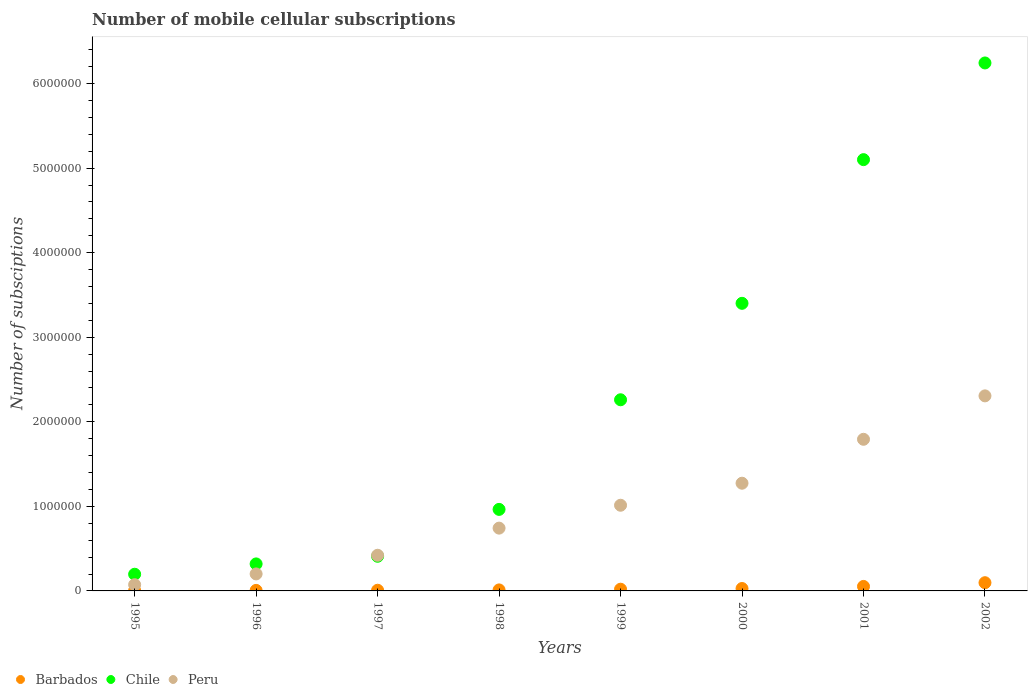Is the number of dotlines equal to the number of legend labels?
Offer a terse response. Yes. What is the number of mobile cellular subscriptions in Chile in 1995?
Make the answer very short. 1.97e+05. Across all years, what is the maximum number of mobile cellular subscriptions in Chile?
Your answer should be compact. 6.24e+06. Across all years, what is the minimum number of mobile cellular subscriptions in Peru?
Your answer should be very brief. 7.35e+04. In which year was the number of mobile cellular subscriptions in Barbados minimum?
Make the answer very short. 1995. What is the total number of mobile cellular subscriptions in Barbados in the graph?
Keep it short and to the point. 2.30e+05. What is the difference between the number of mobile cellular subscriptions in Peru in 1996 and that in 1998?
Make the answer very short. -5.42e+05. What is the difference between the number of mobile cellular subscriptions in Barbados in 1999 and the number of mobile cellular subscriptions in Peru in 1996?
Offer a terse response. -1.81e+05. What is the average number of mobile cellular subscriptions in Barbados per year?
Keep it short and to the point. 2.87e+04. In the year 1999, what is the difference between the number of mobile cellular subscriptions in Barbados and number of mobile cellular subscriptions in Peru?
Make the answer very short. -9.93e+05. In how many years, is the number of mobile cellular subscriptions in Peru greater than 3400000?
Make the answer very short. 0. What is the ratio of the number of mobile cellular subscriptions in Barbados in 1999 to that in 2000?
Your answer should be compact. 0.71. Is the number of mobile cellular subscriptions in Chile in 1998 less than that in 1999?
Your answer should be compact. Yes. Is the difference between the number of mobile cellular subscriptions in Barbados in 1999 and 2000 greater than the difference between the number of mobile cellular subscriptions in Peru in 1999 and 2000?
Provide a succinct answer. Yes. What is the difference between the highest and the second highest number of mobile cellular subscriptions in Chile?
Give a very brief answer. 1.14e+06. What is the difference between the highest and the lowest number of mobile cellular subscriptions in Barbados?
Offer a terse response. 9.26e+04. Does the number of mobile cellular subscriptions in Chile monotonically increase over the years?
Your answer should be very brief. Yes. Is the number of mobile cellular subscriptions in Chile strictly less than the number of mobile cellular subscriptions in Barbados over the years?
Provide a succinct answer. No. How many dotlines are there?
Provide a succinct answer. 3. What is the difference between two consecutive major ticks on the Y-axis?
Provide a short and direct response. 1.00e+06. Does the graph contain grids?
Your answer should be compact. No. How many legend labels are there?
Keep it short and to the point. 3. How are the legend labels stacked?
Offer a terse response. Horizontal. What is the title of the graph?
Give a very brief answer. Number of mobile cellular subscriptions. What is the label or title of the Y-axis?
Your response must be concise. Number of subsciptions. What is the Number of subsciptions in Barbados in 1995?
Offer a terse response. 4614. What is the Number of subsciptions of Chile in 1995?
Your answer should be very brief. 1.97e+05. What is the Number of subsciptions in Peru in 1995?
Provide a short and direct response. 7.35e+04. What is the Number of subsciptions in Barbados in 1996?
Your answer should be compact. 6283. What is the Number of subsciptions of Chile in 1996?
Your answer should be compact. 3.19e+05. What is the Number of subsciptions of Peru in 1996?
Offer a very short reply. 2.01e+05. What is the Number of subsciptions of Barbados in 1997?
Your answer should be compact. 8013. What is the Number of subsciptions in Chile in 1997?
Keep it short and to the point. 4.10e+05. What is the Number of subsciptions in Peru in 1997?
Offer a terse response. 4.22e+05. What is the Number of subsciptions of Barbados in 1998?
Make the answer very short. 1.20e+04. What is the Number of subsciptions in Chile in 1998?
Your answer should be very brief. 9.64e+05. What is the Number of subsciptions of Peru in 1998?
Your response must be concise. 7.43e+05. What is the Number of subsciptions of Barbados in 1999?
Your response must be concise. 2.03e+04. What is the Number of subsciptions in Chile in 1999?
Your response must be concise. 2.26e+06. What is the Number of subsciptions in Peru in 1999?
Keep it short and to the point. 1.01e+06. What is the Number of subsciptions in Barbados in 2000?
Provide a short and direct response. 2.85e+04. What is the Number of subsciptions in Chile in 2000?
Ensure brevity in your answer.  3.40e+06. What is the Number of subsciptions of Peru in 2000?
Make the answer very short. 1.27e+06. What is the Number of subsciptions of Barbados in 2001?
Offer a very short reply. 5.31e+04. What is the Number of subsciptions of Chile in 2001?
Make the answer very short. 5.10e+06. What is the Number of subsciptions of Peru in 2001?
Offer a terse response. 1.79e+06. What is the Number of subsciptions of Barbados in 2002?
Offer a very short reply. 9.72e+04. What is the Number of subsciptions of Chile in 2002?
Make the answer very short. 6.24e+06. What is the Number of subsciptions of Peru in 2002?
Keep it short and to the point. 2.31e+06. Across all years, what is the maximum Number of subsciptions in Barbados?
Your answer should be compact. 9.72e+04. Across all years, what is the maximum Number of subsciptions in Chile?
Your response must be concise. 6.24e+06. Across all years, what is the maximum Number of subsciptions in Peru?
Your answer should be compact. 2.31e+06. Across all years, what is the minimum Number of subsciptions in Barbados?
Offer a terse response. 4614. Across all years, what is the minimum Number of subsciptions in Chile?
Offer a terse response. 1.97e+05. Across all years, what is the minimum Number of subsciptions of Peru?
Keep it short and to the point. 7.35e+04. What is the total Number of subsciptions in Barbados in the graph?
Make the answer very short. 2.30e+05. What is the total Number of subsciptions in Chile in the graph?
Offer a terse response. 1.89e+07. What is the total Number of subsciptions in Peru in the graph?
Keep it short and to the point. 7.83e+06. What is the difference between the Number of subsciptions of Barbados in 1995 and that in 1996?
Your answer should be very brief. -1669. What is the difference between the Number of subsciptions of Chile in 1995 and that in 1996?
Give a very brief answer. -1.22e+05. What is the difference between the Number of subsciptions of Peru in 1995 and that in 1996?
Provide a succinct answer. -1.27e+05. What is the difference between the Number of subsciptions in Barbados in 1995 and that in 1997?
Give a very brief answer. -3399. What is the difference between the Number of subsciptions of Chile in 1995 and that in 1997?
Offer a very short reply. -2.12e+05. What is the difference between the Number of subsciptions of Peru in 1995 and that in 1997?
Provide a succinct answer. -3.48e+05. What is the difference between the Number of subsciptions in Barbados in 1995 and that in 1998?
Your answer should be compact. -7386. What is the difference between the Number of subsciptions of Chile in 1995 and that in 1998?
Provide a short and direct response. -7.67e+05. What is the difference between the Number of subsciptions in Peru in 1995 and that in 1998?
Offer a very short reply. -6.69e+05. What is the difference between the Number of subsciptions in Barbados in 1995 and that in 1999?
Your answer should be very brief. -1.57e+04. What is the difference between the Number of subsciptions of Chile in 1995 and that in 1999?
Make the answer very short. -2.06e+06. What is the difference between the Number of subsciptions in Peru in 1995 and that in 1999?
Provide a succinct answer. -9.40e+05. What is the difference between the Number of subsciptions in Barbados in 1995 and that in 2000?
Offer a terse response. -2.39e+04. What is the difference between the Number of subsciptions of Chile in 1995 and that in 2000?
Provide a succinct answer. -3.20e+06. What is the difference between the Number of subsciptions in Peru in 1995 and that in 2000?
Your answer should be compact. -1.20e+06. What is the difference between the Number of subsciptions of Barbados in 1995 and that in 2001?
Offer a terse response. -4.85e+04. What is the difference between the Number of subsciptions of Chile in 1995 and that in 2001?
Your answer should be very brief. -4.90e+06. What is the difference between the Number of subsciptions of Peru in 1995 and that in 2001?
Offer a very short reply. -1.72e+06. What is the difference between the Number of subsciptions in Barbados in 1995 and that in 2002?
Your answer should be compact. -9.26e+04. What is the difference between the Number of subsciptions of Chile in 1995 and that in 2002?
Offer a terse response. -6.05e+06. What is the difference between the Number of subsciptions of Peru in 1995 and that in 2002?
Your response must be concise. -2.23e+06. What is the difference between the Number of subsciptions in Barbados in 1996 and that in 1997?
Ensure brevity in your answer.  -1730. What is the difference between the Number of subsciptions in Chile in 1996 and that in 1997?
Your response must be concise. -9.03e+04. What is the difference between the Number of subsciptions of Peru in 1996 and that in 1997?
Your answer should be very brief. -2.21e+05. What is the difference between the Number of subsciptions in Barbados in 1996 and that in 1998?
Your answer should be very brief. -5717. What is the difference between the Number of subsciptions in Chile in 1996 and that in 1998?
Offer a very short reply. -6.45e+05. What is the difference between the Number of subsciptions of Peru in 1996 and that in 1998?
Provide a succinct answer. -5.42e+05. What is the difference between the Number of subsciptions in Barbados in 1996 and that in 1999?
Give a very brief answer. -1.40e+04. What is the difference between the Number of subsciptions in Chile in 1996 and that in 1999?
Provide a short and direct response. -1.94e+06. What is the difference between the Number of subsciptions of Peru in 1996 and that in 1999?
Offer a terse response. -8.12e+05. What is the difference between the Number of subsciptions of Barbados in 1996 and that in 2000?
Give a very brief answer. -2.22e+04. What is the difference between the Number of subsciptions of Chile in 1996 and that in 2000?
Offer a very short reply. -3.08e+06. What is the difference between the Number of subsciptions in Peru in 1996 and that in 2000?
Make the answer very short. -1.07e+06. What is the difference between the Number of subsciptions in Barbados in 1996 and that in 2001?
Offer a very short reply. -4.68e+04. What is the difference between the Number of subsciptions of Chile in 1996 and that in 2001?
Offer a terse response. -4.78e+06. What is the difference between the Number of subsciptions in Peru in 1996 and that in 2001?
Your answer should be compact. -1.59e+06. What is the difference between the Number of subsciptions of Barbados in 1996 and that in 2002?
Your answer should be very brief. -9.09e+04. What is the difference between the Number of subsciptions of Chile in 1996 and that in 2002?
Give a very brief answer. -5.92e+06. What is the difference between the Number of subsciptions in Peru in 1996 and that in 2002?
Offer a terse response. -2.11e+06. What is the difference between the Number of subsciptions in Barbados in 1997 and that in 1998?
Provide a short and direct response. -3987. What is the difference between the Number of subsciptions in Chile in 1997 and that in 1998?
Provide a succinct answer. -5.55e+05. What is the difference between the Number of subsciptions of Peru in 1997 and that in 1998?
Offer a terse response. -3.21e+05. What is the difference between the Number of subsciptions of Barbados in 1997 and that in 1999?
Your answer should be compact. -1.23e+04. What is the difference between the Number of subsciptions in Chile in 1997 and that in 1999?
Offer a very short reply. -1.85e+06. What is the difference between the Number of subsciptions in Peru in 1997 and that in 1999?
Keep it short and to the point. -5.92e+05. What is the difference between the Number of subsciptions in Barbados in 1997 and that in 2000?
Make the answer very short. -2.05e+04. What is the difference between the Number of subsciptions in Chile in 1997 and that in 2000?
Offer a very short reply. -2.99e+06. What is the difference between the Number of subsciptions in Peru in 1997 and that in 2000?
Offer a very short reply. -8.52e+05. What is the difference between the Number of subsciptions of Barbados in 1997 and that in 2001?
Keep it short and to the point. -4.51e+04. What is the difference between the Number of subsciptions in Chile in 1997 and that in 2001?
Provide a succinct answer. -4.69e+06. What is the difference between the Number of subsciptions in Peru in 1997 and that in 2001?
Your response must be concise. -1.37e+06. What is the difference between the Number of subsciptions in Barbados in 1997 and that in 2002?
Your answer should be compact. -8.92e+04. What is the difference between the Number of subsciptions in Chile in 1997 and that in 2002?
Keep it short and to the point. -5.83e+06. What is the difference between the Number of subsciptions of Peru in 1997 and that in 2002?
Your answer should be compact. -1.89e+06. What is the difference between the Number of subsciptions of Barbados in 1998 and that in 1999?
Keep it short and to the point. -8309. What is the difference between the Number of subsciptions of Chile in 1998 and that in 1999?
Offer a very short reply. -1.30e+06. What is the difference between the Number of subsciptions of Peru in 1998 and that in 1999?
Offer a very short reply. -2.71e+05. What is the difference between the Number of subsciptions in Barbados in 1998 and that in 2000?
Provide a succinct answer. -1.65e+04. What is the difference between the Number of subsciptions in Chile in 1998 and that in 2000?
Keep it short and to the point. -2.44e+06. What is the difference between the Number of subsciptions of Peru in 1998 and that in 2000?
Your response must be concise. -5.31e+05. What is the difference between the Number of subsciptions in Barbados in 1998 and that in 2001?
Provide a succinct answer. -4.11e+04. What is the difference between the Number of subsciptions of Chile in 1998 and that in 2001?
Keep it short and to the point. -4.14e+06. What is the difference between the Number of subsciptions of Peru in 1998 and that in 2001?
Offer a very short reply. -1.05e+06. What is the difference between the Number of subsciptions of Barbados in 1998 and that in 2002?
Offer a very short reply. -8.52e+04. What is the difference between the Number of subsciptions of Chile in 1998 and that in 2002?
Provide a short and direct response. -5.28e+06. What is the difference between the Number of subsciptions in Peru in 1998 and that in 2002?
Provide a short and direct response. -1.56e+06. What is the difference between the Number of subsciptions of Barbados in 1999 and that in 2000?
Your response must be concise. -8158. What is the difference between the Number of subsciptions of Chile in 1999 and that in 2000?
Offer a terse response. -1.14e+06. What is the difference between the Number of subsciptions of Peru in 1999 and that in 2000?
Ensure brevity in your answer.  -2.61e+05. What is the difference between the Number of subsciptions of Barbados in 1999 and that in 2001?
Ensure brevity in your answer.  -3.28e+04. What is the difference between the Number of subsciptions in Chile in 1999 and that in 2001?
Your answer should be very brief. -2.84e+06. What is the difference between the Number of subsciptions of Peru in 1999 and that in 2001?
Your answer should be compact. -7.80e+05. What is the difference between the Number of subsciptions in Barbados in 1999 and that in 2002?
Offer a very short reply. -7.69e+04. What is the difference between the Number of subsciptions in Chile in 1999 and that in 2002?
Ensure brevity in your answer.  -3.98e+06. What is the difference between the Number of subsciptions of Peru in 1999 and that in 2002?
Offer a very short reply. -1.29e+06. What is the difference between the Number of subsciptions of Barbados in 2000 and that in 2001?
Your answer should be very brief. -2.46e+04. What is the difference between the Number of subsciptions in Chile in 2000 and that in 2001?
Provide a succinct answer. -1.70e+06. What is the difference between the Number of subsciptions of Peru in 2000 and that in 2001?
Offer a terse response. -5.19e+05. What is the difference between the Number of subsciptions in Barbados in 2000 and that in 2002?
Your response must be concise. -6.87e+04. What is the difference between the Number of subsciptions in Chile in 2000 and that in 2002?
Offer a terse response. -2.84e+06. What is the difference between the Number of subsciptions of Peru in 2000 and that in 2002?
Make the answer very short. -1.03e+06. What is the difference between the Number of subsciptions in Barbados in 2001 and that in 2002?
Your answer should be very brief. -4.41e+04. What is the difference between the Number of subsciptions of Chile in 2001 and that in 2002?
Make the answer very short. -1.14e+06. What is the difference between the Number of subsciptions of Peru in 2001 and that in 2002?
Your response must be concise. -5.14e+05. What is the difference between the Number of subsciptions in Barbados in 1995 and the Number of subsciptions in Chile in 1996?
Make the answer very short. -3.15e+05. What is the difference between the Number of subsciptions in Barbados in 1995 and the Number of subsciptions in Peru in 1996?
Provide a short and direct response. -1.96e+05. What is the difference between the Number of subsciptions of Chile in 1995 and the Number of subsciptions of Peru in 1996?
Your answer should be compact. -3658. What is the difference between the Number of subsciptions in Barbados in 1995 and the Number of subsciptions in Chile in 1997?
Give a very brief answer. -4.05e+05. What is the difference between the Number of subsciptions in Barbados in 1995 and the Number of subsciptions in Peru in 1997?
Keep it short and to the point. -4.17e+05. What is the difference between the Number of subsciptions of Chile in 1995 and the Number of subsciptions of Peru in 1997?
Make the answer very short. -2.24e+05. What is the difference between the Number of subsciptions of Barbados in 1995 and the Number of subsciptions of Chile in 1998?
Offer a very short reply. -9.60e+05. What is the difference between the Number of subsciptions of Barbados in 1995 and the Number of subsciptions of Peru in 1998?
Provide a succinct answer. -7.38e+05. What is the difference between the Number of subsciptions in Chile in 1995 and the Number of subsciptions in Peru in 1998?
Offer a very short reply. -5.45e+05. What is the difference between the Number of subsciptions of Barbados in 1995 and the Number of subsciptions of Chile in 1999?
Your answer should be very brief. -2.26e+06. What is the difference between the Number of subsciptions of Barbados in 1995 and the Number of subsciptions of Peru in 1999?
Keep it short and to the point. -1.01e+06. What is the difference between the Number of subsciptions of Chile in 1995 and the Number of subsciptions of Peru in 1999?
Your response must be concise. -8.16e+05. What is the difference between the Number of subsciptions of Barbados in 1995 and the Number of subsciptions of Chile in 2000?
Offer a very short reply. -3.40e+06. What is the difference between the Number of subsciptions in Barbados in 1995 and the Number of subsciptions in Peru in 2000?
Ensure brevity in your answer.  -1.27e+06. What is the difference between the Number of subsciptions in Chile in 1995 and the Number of subsciptions in Peru in 2000?
Ensure brevity in your answer.  -1.08e+06. What is the difference between the Number of subsciptions in Barbados in 1995 and the Number of subsciptions in Chile in 2001?
Your response must be concise. -5.10e+06. What is the difference between the Number of subsciptions in Barbados in 1995 and the Number of subsciptions in Peru in 2001?
Keep it short and to the point. -1.79e+06. What is the difference between the Number of subsciptions of Chile in 1995 and the Number of subsciptions of Peru in 2001?
Your response must be concise. -1.60e+06. What is the difference between the Number of subsciptions in Barbados in 1995 and the Number of subsciptions in Chile in 2002?
Ensure brevity in your answer.  -6.24e+06. What is the difference between the Number of subsciptions of Barbados in 1995 and the Number of subsciptions of Peru in 2002?
Your answer should be compact. -2.30e+06. What is the difference between the Number of subsciptions in Chile in 1995 and the Number of subsciptions in Peru in 2002?
Your answer should be very brief. -2.11e+06. What is the difference between the Number of subsciptions in Barbados in 1996 and the Number of subsciptions in Chile in 1997?
Keep it short and to the point. -4.03e+05. What is the difference between the Number of subsciptions of Barbados in 1996 and the Number of subsciptions of Peru in 1997?
Keep it short and to the point. -4.16e+05. What is the difference between the Number of subsciptions in Chile in 1996 and the Number of subsciptions in Peru in 1997?
Provide a succinct answer. -1.02e+05. What is the difference between the Number of subsciptions in Barbados in 1996 and the Number of subsciptions in Chile in 1998?
Offer a very short reply. -9.58e+05. What is the difference between the Number of subsciptions in Barbados in 1996 and the Number of subsciptions in Peru in 1998?
Ensure brevity in your answer.  -7.36e+05. What is the difference between the Number of subsciptions of Chile in 1996 and the Number of subsciptions of Peru in 1998?
Your answer should be compact. -4.23e+05. What is the difference between the Number of subsciptions of Barbados in 1996 and the Number of subsciptions of Chile in 1999?
Your answer should be very brief. -2.25e+06. What is the difference between the Number of subsciptions in Barbados in 1996 and the Number of subsciptions in Peru in 1999?
Offer a very short reply. -1.01e+06. What is the difference between the Number of subsciptions of Chile in 1996 and the Number of subsciptions of Peru in 1999?
Provide a short and direct response. -6.94e+05. What is the difference between the Number of subsciptions of Barbados in 1996 and the Number of subsciptions of Chile in 2000?
Provide a short and direct response. -3.40e+06. What is the difference between the Number of subsciptions of Barbados in 1996 and the Number of subsciptions of Peru in 2000?
Your response must be concise. -1.27e+06. What is the difference between the Number of subsciptions in Chile in 1996 and the Number of subsciptions in Peru in 2000?
Make the answer very short. -9.54e+05. What is the difference between the Number of subsciptions of Barbados in 1996 and the Number of subsciptions of Chile in 2001?
Offer a very short reply. -5.09e+06. What is the difference between the Number of subsciptions of Barbados in 1996 and the Number of subsciptions of Peru in 2001?
Offer a very short reply. -1.79e+06. What is the difference between the Number of subsciptions of Chile in 1996 and the Number of subsciptions of Peru in 2001?
Give a very brief answer. -1.47e+06. What is the difference between the Number of subsciptions of Barbados in 1996 and the Number of subsciptions of Chile in 2002?
Offer a very short reply. -6.24e+06. What is the difference between the Number of subsciptions of Barbados in 1996 and the Number of subsciptions of Peru in 2002?
Ensure brevity in your answer.  -2.30e+06. What is the difference between the Number of subsciptions of Chile in 1996 and the Number of subsciptions of Peru in 2002?
Keep it short and to the point. -1.99e+06. What is the difference between the Number of subsciptions of Barbados in 1997 and the Number of subsciptions of Chile in 1998?
Offer a terse response. -9.56e+05. What is the difference between the Number of subsciptions in Barbados in 1997 and the Number of subsciptions in Peru in 1998?
Your answer should be very brief. -7.35e+05. What is the difference between the Number of subsciptions of Chile in 1997 and the Number of subsciptions of Peru in 1998?
Provide a succinct answer. -3.33e+05. What is the difference between the Number of subsciptions of Barbados in 1997 and the Number of subsciptions of Chile in 1999?
Your answer should be compact. -2.25e+06. What is the difference between the Number of subsciptions in Barbados in 1997 and the Number of subsciptions in Peru in 1999?
Your response must be concise. -1.01e+06. What is the difference between the Number of subsciptions in Chile in 1997 and the Number of subsciptions in Peru in 1999?
Offer a very short reply. -6.04e+05. What is the difference between the Number of subsciptions of Barbados in 1997 and the Number of subsciptions of Chile in 2000?
Give a very brief answer. -3.39e+06. What is the difference between the Number of subsciptions in Barbados in 1997 and the Number of subsciptions in Peru in 2000?
Your answer should be very brief. -1.27e+06. What is the difference between the Number of subsciptions in Chile in 1997 and the Number of subsciptions in Peru in 2000?
Your answer should be compact. -8.64e+05. What is the difference between the Number of subsciptions in Barbados in 1997 and the Number of subsciptions in Chile in 2001?
Offer a terse response. -5.09e+06. What is the difference between the Number of subsciptions in Barbados in 1997 and the Number of subsciptions in Peru in 2001?
Ensure brevity in your answer.  -1.79e+06. What is the difference between the Number of subsciptions of Chile in 1997 and the Number of subsciptions of Peru in 2001?
Offer a very short reply. -1.38e+06. What is the difference between the Number of subsciptions of Barbados in 1997 and the Number of subsciptions of Chile in 2002?
Your response must be concise. -6.24e+06. What is the difference between the Number of subsciptions of Barbados in 1997 and the Number of subsciptions of Peru in 2002?
Your response must be concise. -2.30e+06. What is the difference between the Number of subsciptions of Chile in 1997 and the Number of subsciptions of Peru in 2002?
Provide a short and direct response. -1.90e+06. What is the difference between the Number of subsciptions of Barbados in 1998 and the Number of subsciptions of Chile in 1999?
Your answer should be very brief. -2.25e+06. What is the difference between the Number of subsciptions of Barbados in 1998 and the Number of subsciptions of Peru in 1999?
Provide a short and direct response. -1.00e+06. What is the difference between the Number of subsciptions of Chile in 1998 and the Number of subsciptions of Peru in 1999?
Give a very brief answer. -4.91e+04. What is the difference between the Number of subsciptions in Barbados in 1998 and the Number of subsciptions in Chile in 2000?
Your answer should be very brief. -3.39e+06. What is the difference between the Number of subsciptions of Barbados in 1998 and the Number of subsciptions of Peru in 2000?
Your answer should be very brief. -1.26e+06. What is the difference between the Number of subsciptions in Chile in 1998 and the Number of subsciptions in Peru in 2000?
Offer a terse response. -3.10e+05. What is the difference between the Number of subsciptions in Barbados in 1998 and the Number of subsciptions in Chile in 2001?
Ensure brevity in your answer.  -5.09e+06. What is the difference between the Number of subsciptions in Barbados in 1998 and the Number of subsciptions in Peru in 2001?
Ensure brevity in your answer.  -1.78e+06. What is the difference between the Number of subsciptions in Chile in 1998 and the Number of subsciptions in Peru in 2001?
Your answer should be compact. -8.29e+05. What is the difference between the Number of subsciptions of Barbados in 1998 and the Number of subsciptions of Chile in 2002?
Your response must be concise. -6.23e+06. What is the difference between the Number of subsciptions in Barbados in 1998 and the Number of subsciptions in Peru in 2002?
Make the answer very short. -2.29e+06. What is the difference between the Number of subsciptions of Chile in 1998 and the Number of subsciptions of Peru in 2002?
Offer a terse response. -1.34e+06. What is the difference between the Number of subsciptions of Barbados in 1999 and the Number of subsciptions of Chile in 2000?
Provide a short and direct response. -3.38e+06. What is the difference between the Number of subsciptions in Barbados in 1999 and the Number of subsciptions in Peru in 2000?
Ensure brevity in your answer.  -1.25e+06. What is the difference between the Number of subsciptions of Chile in 1999 and the Number of subsciptions of Peru in 2000?
Provide a succinct answer. 9.87e+05. What is the difference between the Number of subsciptions of Barbados in 1999 and the Number of subsciptions of Chile in 2001?
Ensure brevity in your answer.  -5.08e+06. What is the difference between the Number of subsciptions of Barbados in 1999 and the Number of subsciptions of Peru in 2001?
Give a very brief answer. -1.77e+06. What is the difference between the Number of subsciptions in Chile in 1999 and the Number of subsciptions in Peru in 2001?
Give a very brief answer. 4.67e+05. What is the difference between the Number of subsciptions in Barbados in 1999 and the Number of subsciptions in Chile in 2002?
Offer a very short reply. -6.22e+06. What is the difference between the Number of subsciptions of Barbados in 1999 and the Number of subsciptions of Peru in 2002?
Your response must be concise. -2.29e+06. What is the difference between the Number of subsciptions of Chile in 1999 and the Number of subsciptions of Peru in 2002?
Offer a terse response. -4.63e+04. What is the difference between the Number of subsciptions of Barbados in 2000 and the Number of subsciptions of Chile in 2001?
Offer a very short reply. -5.07e+06. What is the difference between the Number of subsciptions in Barbados in 2000 and the Number of subsciptions in Peru in 2001?
Provide a succinct answer. -1.76e+06. What is the difference between the Number of subsciptions of Chile in 2000 and the Number of subsciptions of Peru in 2001?
Provide a succinct answer. 1.61e+06. What is the difference between the Number of subsciptions of Barbados in 2000 and the Number of subsciptions of Chile in 2002?
Your answer should be compact. -6.22e+06. What is the difference between the Number of subsciptions of Barbados in 2000 and the Number of subsciptions of Peru in 2002?
Offer a terse response. -2.28e+06. What is the difference between the Number of subsciptions of Chile in 2000 and the Number of subsciptions of Peru in 2002?
Your response must be concise. 1.09e+06. What is the difference between the Number of subsciptions of Barbados in 2001 and the Number of subsciptions of Chile in 2002?
Offer a very short reply. -6.19e+06. What is the difference between the Number of subsciptions in Barbados in 2001 and the Number of subsciptions in Peru in 2002?
Make the answer very short. -2.25e+06. What is the difference between the Number of subsciptions in Chile in 2001 and the Number of subsciptions in Peru in 2002?
Provide a succinct answer. 2.79e+06. What is the average Number of subsciptions in Barbados per year?
Provide a short and direct response. 2.87e+04. What is the average Number of subsciptions of Chile per year?
Keep it short and to the point. 2.36e+06. What is the average Number of subsciptions in Peru per year?
Your answer should be compact. 9.78e+05. In the year 1995, what is the difference between the Number of subsciptions of Barbados and Number of subsciptions of Chile?
Give a very brief answer. -1.93e+05. In the year 1995, what is the difference between the Number of subsciptions in Barbados and Number of subsciptions in Peru?
Provide a succinct answer. -6.89e+04. In the year 1995, what is the difference between the Number of subsciptions in Chile and Number of subsciptions in Peru?
Your answer should be very brief. 1.24e+05. In the year 1996, what is the difference between the Number of subsciptions in Barbados and Number of subsciptions in Chile?
Give a very brief answer. -3.13e+05. In the year 1996, what is the difference between the Number of subsciptions in Barbados and Number of subsciptions in Peru?
Make the answer very short. -1.95e+05. In the year 1996, what is the difference between the Number of subsciptions in Chile and Number of subsciptions in Peru?
Keep it short and to the point. 1.19e+05. In the year 1997, what is the difference between the Number of subsciptions of Barbados and Number of subsciptions of Chile?
Keep it short and to the point. -4.02e+05. In the year 1997, what is the difference between the Number of subsciptions in Barbados and Number of subsciptions in Peru?
Your answer should be compact. -4.14e+05. In the year 1997, what is the difference between the Number of subsciptions of Chile and Number of subsciptions of Peru?
Offer a terse response. -1.21e+04. In the year 1998, what is the difference between the Number of subsciptions in Barbados and Number of subsciptions in Chile?
Your answer should be compact. -9.52e+05. In the year 1998, what is the difference between the Number of subsciptions in Barbados and Number of subsciptions in Peru?
Your answer should be very brief. -7.31e+05. In the year 1998, what is the difference between the Number of subsciptions of Chile and Number of subsciptions of Peru?
Offer a terse response. 2.22e+05. In the year 1999, what is the difference between the Number of subsciptions of Barbados and Number of subsciptions of Chile?
Keep it short and to the point. -2.24e+06. In the year 1999, what is the difference between the Number of subsciptions of Barbados and Number of subsciptions of Peru?
Your answer should be very brief. -9.93e+05. In the year 1999, what is the difference between the Number of subsciptions of Chile and Number of subsciptions of Peru?
Provide a short and direct response. 1.25e+06. In the year 2000, what is the difference between the Number of subsciptions of Barbados and Number of subsciptions of Chile?
Your answer should be compact. -3.37e+06. In the year 2000, what is the difference between the Number of subsciptions of Barbados and Number of subsciptions of Peru?
Your answer should be very brief. -1.25e+06. In the year 2000, what is the difference between the Number of subsciptions of Chile and Number of subsciptions of Peru?
Provide a short and direct response. 2.13e+06. In the year 2001, what is the difference between the Number of subsciptions of Barbados and Number of subsciptions of Chile?
Your response must be concise. -5.05e+06. In the year 2001, what is the difference between the Number of subsciptions of Barbados and Number of subsciptions of Peru?
Provide a short and direct response. -1.74e+06. In the year 2001, what is the difference between the Number of subsciptions in Chile and Number of subsciptions in Peru?
Provide a short and direct response. 3.31e+06. In the year 2002, what is the difference between the Number of subsciptions of Barbados and Number of subsciptions of Chile?
Offer a very short reply. -6.15e+06. In the year 2002, what is the difference between the Number of subsciptions in Barbados and Number of subsciptions in Peru?
Your answer should be compact. -2.21e+06. In the year 2002, what is the difference between the Number of subsciptions of Chile and Number of subsciptions of Peru?
Provide a succinct answer. 3.94e+06. What is the ratio of the Number of subsciptions in Barbados in 1995 to that in 1996?
Your answer should be very brief. 0.73. What is the ratio of the Number of subsciptions in Chile in 1995 to that in 1996?
Offer a terse response. 0.62. What is the ratio of the Number of subsciptions of Peru in 1995 to that in 1996?
Your answer should be very brief. 0.37. What is the ratio of the Number of subsciptions in Barbados in 1995 to that in 1997?
Give a very brief answer. 0.58. What is the ratio of the Number of subsciptions in Chile in 1995 to that in 1997?
Your response must be concise. 0.48. What is the ratio of the Number of subsciptions of Peru in 1995 to that in 1997?
Make the answer very short. 0.17. What is the ratio of the Number of subsciptions of Barbados in 1995 to that in 1998?
Offer a very short reply. 0.38. What is the ratio of the Number of subsciptions of Chile in 1995 to that in 1998?
Ensure brevity in your answer.  0.2. What is the ratio of the Number of subsciptions in Peru in 1995 to that in 1998?
Offer a terse response. 0.1. What is the ratio of the Number of subsciptions in Barbados in 1995 to that in 1999?
Your answer should be compact. 0.23. What is the ratio of the Number of subsciptions of Chile in 1995 to that in 1999?
Provide a succinct answer. 0.09. What is the ratio of the Number of subsciptions of Peru in 1995 to that in 1999?
Provide a short and direct response. 0.07. What is the ratio of the Number of subsciptions in Barbados in 1995 to that in 2000?
Make the answer very short. 0.16. What is the ratio of the Number of subsciptions of Chile in 1995 to that in 2000?
Your response must be concise. 0.06. What is the ratio of the Number of subsciptions of Peru in 1995 to that in 2000?
Your answer should be compact. 0.06. What is the ratio of the Number of subsciptions of Barbados in 1995 to that in 2001?
Provide a succinct answer. 0.09. What is the ratio of the Number of subsciptions in Chile in 1995 to that in 2001?
Ensure brevity in your answer.  0.04. What is the ratio of the Number of subsciptions of Peru in 1995 to that in 2001?
Ensure brevity in your answer.  0.04. What is the ratio of the Number of subsciptions of Barbados in 1995 to that in 2002?
Make the answer very short. 0.05. What is the ratio of the Number of subsciptions of Chile in 1995 to that in 2002?
Make the answer very short. 0.03. What is the ratio of the Number of subsciptions of Peru in 1995 to that in 2002?
Ensure brevity in your answer.  0.03. What is the ratio of the Number of subsciptions in Barbados in 1996 to that in 1997?
Keep it short and to the point. 0.78. What is the ratio of the Number of subsciptions in Chile in 1996 to that in 1997?
Your response must be concise. 0.78. What is the ratio of the Number of subsciptions in Peru in 1996 to that in 1997?
Provide a succinct answer. 0.48. What is the ratio of the Number of subsciptions in Barbados in 1996 to that in 1998?
Offer a very short reply. 0.52. What is the ratio of the Number of subsciptions in Chile in 1996 to that in 1998?
Offer a terse response. 0.33. What is the ratio of the Number of subsciptions of Peru in 1996 to that in 1998?
Give a very brief answer. 0.27. What is the ratio of the Number of subsciptions of Barbados in 1996 to that in 1999?
Provide a succinct answer. 0.31. What is the ratio of the Number of subsciptions in Chile in 1996 to that in 1999?
Your response must be concise. 0.14. What is the ratio of the Number of subsciptions in Peru in 1996 to that in 1999?
Provide a succinct answer. 0.2. What is the ratio of the Number of subsciptions of Barbados in 1996 to that in 2000?
Your answer should be compact. 0.22. What is the ratio of the Number of subsciptions in Chile in 1996 to that in 2000?
Provide a short and direct response. 0.09. What is the ratio of the Number of subsciptions of Peru in 1996 to that in 2000?
Ensure brevity in your answer.  0.16. What is the ratio of the Number of subsciptions of Barbados in 1996 to that in 2001?
Your answer should be very brief. 0.12. What is the ratio of the Number of subsciptions in Chile in 1996 to that in 2001?
Offer a terse response. 0.06. What is the ratio of the Number of subsciptions of Peru in 1996 to that in 2001?
Your answer should be very brief. 0.11. What is the ratio of the Number of subsciptions in Barbados in 1996 to that in 2002?
Your answer should be very brief. 0.06. What is the ratio of the Number of subsciptions of Chile in 1996 to that in 2002?
Offer a very short reply. 0.05. What is the ratio of the Number of subsciptions of Peru in 1996 to that in 2002?
Provide a succinct answer. 0.09. What is the ratio of the Number of subsciptions of Barbados in 1997 to that in 1998?
Ensure brevity in your answer.  0.67. What is the ratio of the Number of subsciptions in Chile in 1997 to that in 1998?
Provide a succinct answer. 0.42. What is the ratio of the Number of subsciptions in Peru in 1997 to that in 1998?
Make the answer very short. 0.57. What is the ratio of the Number of subsciptions in Barbados in 1997 to that in 1999?
Provide a short and direct response. 0.39. What is the ratio of the Number of subsciptions in Chile in 1997 to that in 1999?
Provide a succinct answer. 0.18. What is the ratio of the Number of subsciptions of Peru in 1997 to that in 1999?
Ensure brevity in your answer.  0.42. What is the ratio of the Number of subsciptions in Barbados in 1997 to that in 2000?
Your response must be concise. 0.28. What is the ratio of the Number of subsciptions of Chile in 1997 to that in 2000?
Your response must be concise. 0.12. What is the ratio of the Number of subsciptions of Peru in 1997 to that in 2000?
Make the answer very short. 0.33. What is the ratio of the Number of subsciptions in Barbados in 1997 to that in 2001?
Provide a succinct answer. 0.15. What is the ratio of the Number of subsciptions of Chile in 1997 to that in 2001?
Your answer should be compact. 0.08. What is the ratio of the Number of subsciptions of Peru in 1997 to that in 2001?
Make the answer very short. 0.24. What is the ratio of the Number of subsciptions in Barbados in 1997 to that in 2002?
Give a very brief answer. 0.08. What is the ratio of the Number of subsciptions in Chile in 1997 to that in 2002?
Provide a short and direct response. 0.07. What is the ratio of the Number of subsciptions in Peru in 1997 to that in 2002?
Offer a terse response. 0.18. What is the ratio of the Number of subsciptions of Barbados in 1998 to that in 1999?
Offer a very short reply. 0.59. What is the ratio of the Number of subsciptions of Chile in 1998 to that in 1999?
Give a very brief answer. 0.43. What is the ratio of the Number of subsciptions in Peru in 1998 to that in 1999?
Offer a very short reply. 0.73. What is the ratio of the Number of subsciptions in Barbados in 1998 to that in 2000?
Your response must be concise. 0.42. What is the ratio of the Number of subsciptions in Chile in 1998 to that in 2000?
Your response must be concise. 0.28. What is the ratio of the Number of subsciptions in Peru in 1998 to that in 2000?
Provide a short and direct response. 0.58. What is the ratio of the Number of subsciptions of Barbados in 1998 to that in 2001?
Your response must be concise. 0.23. What is the ratio of the Number of subsciptions in Chile in 1998 to that in 2001?
Your answer should be very brief. 0.19. What is the ratio of the Number of subsciptions of Peru in 1998 to that in 2001?
Your answer should be compact. 0.41. What is the ratio of the Number of subsciptions in Barbados in 1998 to that in 2002?
Keep it short and to the point. 0.12. What is the ratio of the Number of subsciptions of Chile in 1998 to that in 2002?
Your answer should be compact. 0.15. What is the ratio of the Number of subsciptions in Peru in 1998 to that in 2002?
Give a very brief answer. 0.32. What is the ratio of the Number of subsciptions of Barbados in 1999 to that in 2000?
Your response must be concise. 0.71. What is the ratio of the Number of subsciptions in Chile in 1999 to that in 2000?
Your response must be concise. 0.66. What is the ratio of the Number of subsciptions in Peru in 1999 to that in 2000?
Keep it short and to the point. 0.8. What is the ratio of the Number of subsciptions of Barbados in 1999 to that in 2001?
Provide a succinct answer. 0.38. What is the ratio of the Number of subsciptions of Chile in 1999 to that in 2001?
Give a very brief answer. 0.44. What is the ratio of the Number of subsciptions in Peru in 1999 to that in 2001?
Your answer should be compact. 0.57. What is the ratio of the Number of subsciptions in Barbados in 1999 to that in 2002?
Offer a terse response. 0.21. What is the ratio of the Number of subsciptions in Chile in 1999 to that in 2002?
Your response must be concise. 0.36. What is the ratio of the Number of subsciptions in Peru in 1999 to that in 2002?
Offer a very short reply. 0.44. What is the ratio of the Number of subsciptions in Barbados in 2000 to that in 2001?
Your response must be concise. 0.54. What is the ratio of the Number of subsciptions in Chile in 2000 to that in 2001?
Offer a terse response. 0.67. What is the ratio of the Number of subsciptions in Peru in 2000 to that in 2001?
Provide a succinct answer. 0.71. What is the ratio of the Number of subsciptions in Barbados in 2000 to that in 2002?
Offer a very short reply. 0.29. What is the ratio of the Number of subsciptions in Chile in 2000 to that in 2002?
Keep it short and to the point. 0.54. What is the ratio of the Number of subsciptions of Peru in 2000 to that in 2002?
Offer a very short reply. 0.55. What is the ratio of the Number of subsciptions in Barbados in 2001 to that in 2002?
Offer a very short reply. 0.55. What is the ratio of the Number of subsciptions in Chile in 2001 to that in 2002?
Keep it short and to the point. 0.82. What is the ratio of the Number of subsciptions of Peru in 2001 to that in 2002?
Give a very brief answer. 0.78. What is the difference between the highest and the second highest Number of subsciptions in Barbados?
Provide a succinct answer. 4.41e+04. What is the difference between the highest and the second highest Number of subsciptions of Chile?
Offer a terse response. 1.14e+06. What is the difference between the highest and the second highest Number of subsciptions in Peru?
Ensure brevity in your answer.  5.14e+05. What is the difference between the highest and the lowest Number of subsciptions in Barbados?
Your response must be concise. 9.26e+04. What is the difference between the highest and the lowest Number of subsciptions of Chile?
Offer a very short reply. 6.05e+06. What is the difference between the highest and the lowest Number of subsciptions in Peru?
Ensure brevity in your answer.  2.23e+06. 